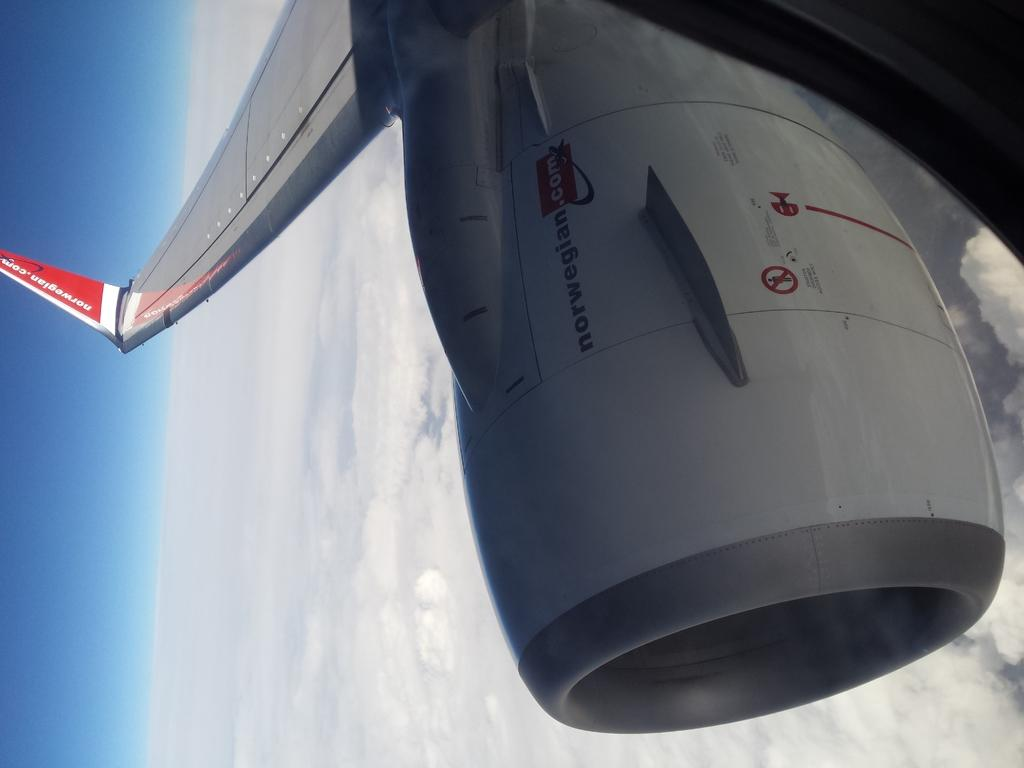<image>
Present a compact description of the photo's key features. A plane in the air reads "norwegian.com" on the side. 